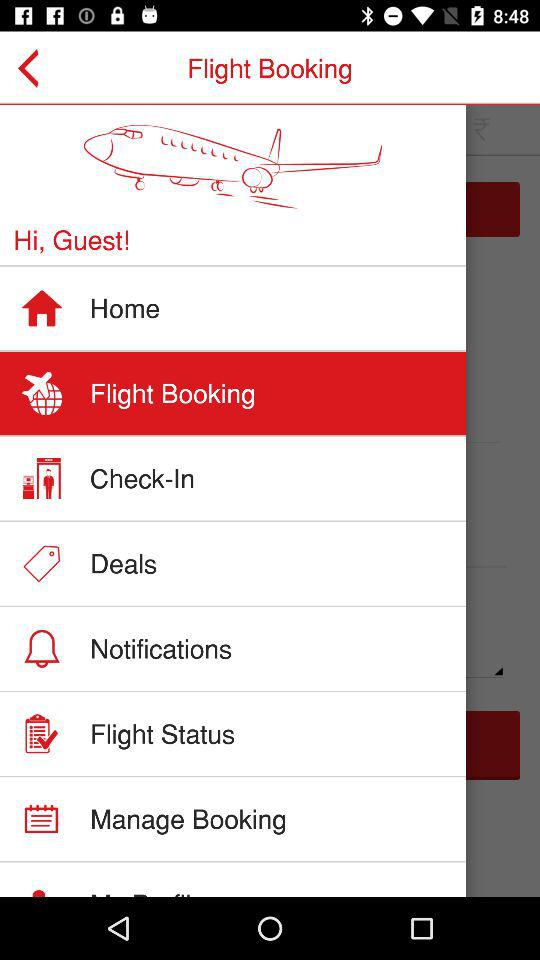What's the selected menu option? The selected menu option is "Flight Booking". 